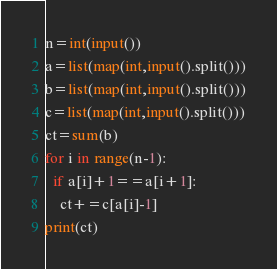Convert code to text. <code><loc_0><loc_0><loc_500><loc_500><_Python_>n=int(input())
a=list(map(int,input().split()))
b=list(map(int,input().split()))
c=list(map(int,input().split()))
ct=sum(b)
for i in range(n-1):
  if a[i]+1==a[i+1]:
    ct+=c[a[i]-1]
print(ct)</code> 